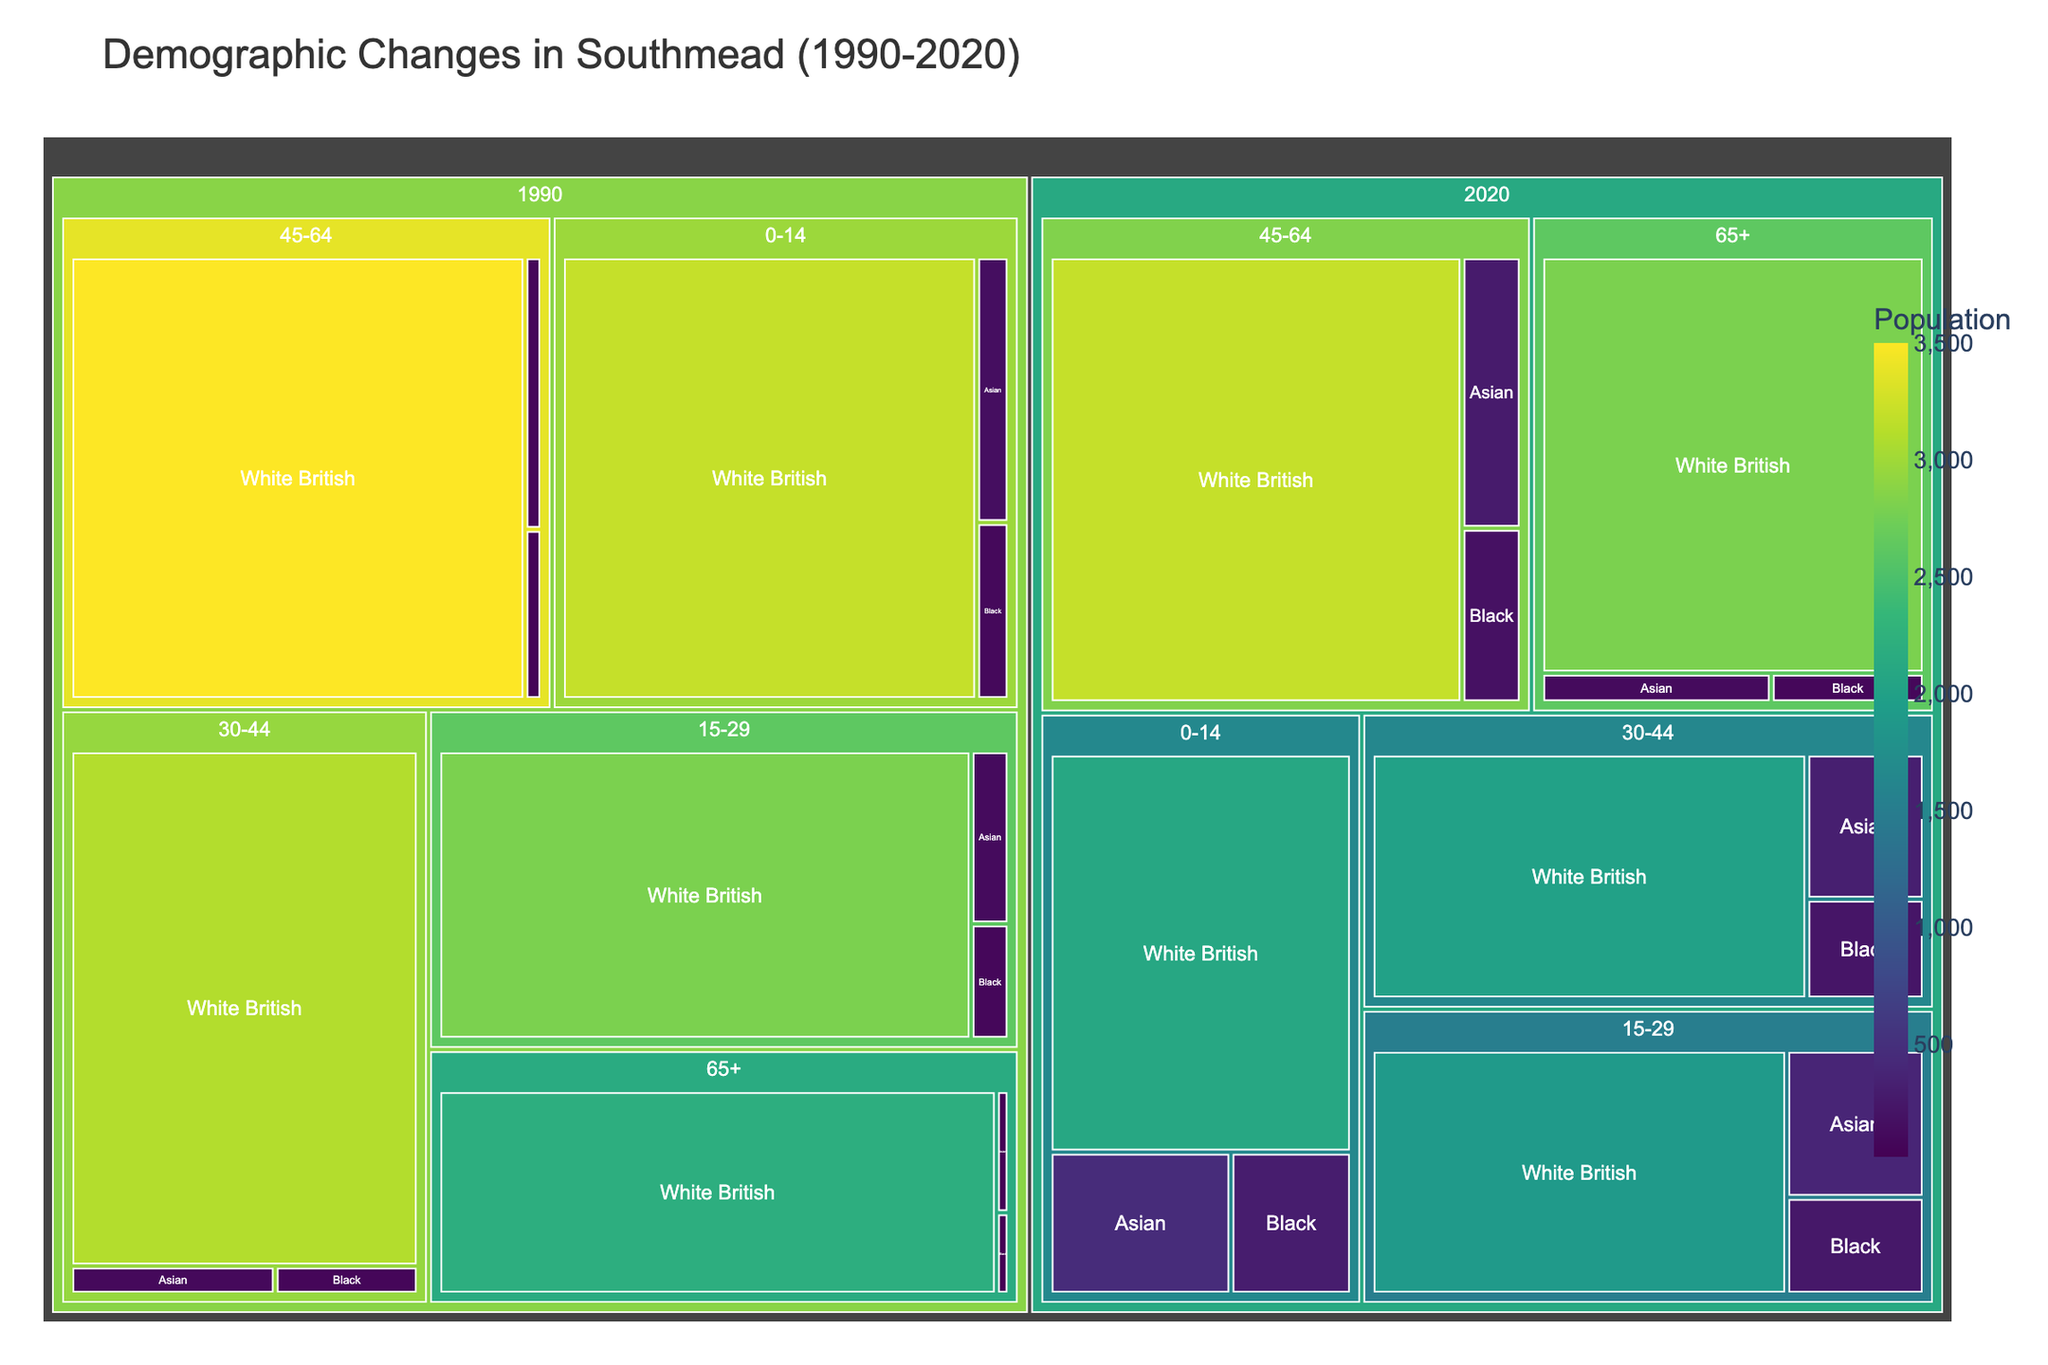What is the title of the figure? The title of the figure is written at the top, indicating the main subject of the visualization
Answer: Demographic Changes in Southmead (1990-2020) How many years are represented in the treemap? By examining the labels and structure of the treemap, you can identify the number of distinct years shown
Answer: 2 (1990 and 2020) Which age group has the largest population of White British in 2020? To determine this, locate the 2020 section, filter by the White British ethnicity, and compare the population values across different age groups
Answer: 65+ Which ethnic group saw the highest increase in the 0-14 age group from 1990 to 2020? Examine the population values for each ethnic group in the 0-14 age group for both years and calculate the differences. The highest positive difference indicates the largest increase
Answer: Asian What was the population of Black ethnicity in the 15-29 age group in 2020? To find this, navigate to the 2020 section, then the 15-29 age group, and look at the Black ethnicity population value
Answer: 250 How does the population of Asians in the 30-44 age group in 2020 compare to 1990? Compare the population values of Asians in the 30-44 age group between the two years by examining each segment
Answer: Increased from 100 to 320 What is the overall trend for the 45-64 age group from 1990 to 2020? By analyzing the population changes across all ethnicities in the 45-64 age group from 1990 to 2020, you can identify the overall trend
Answer: Overall population increased Which age group saw a decrease in the White British population from 1990 to 2020? Identify the White British sections for each age group and compare the population from 1990 to 2020 to see which ones decreased
Answer: 0-14, 15-29, 30-44 What is the color scale used in the treemap? Observe the visual representation of colors in the treemap and describe the gradient used for population values
Answer: Viridis What is the approximate population difference for the Black ethnicity in the 45-64 age group between 1990 to 2020? Calculate the difference by subtracting the 1990 population from the 2020 population for the Black ethnicity in the 45-64 age group (180 - 50)
Answer: 130 